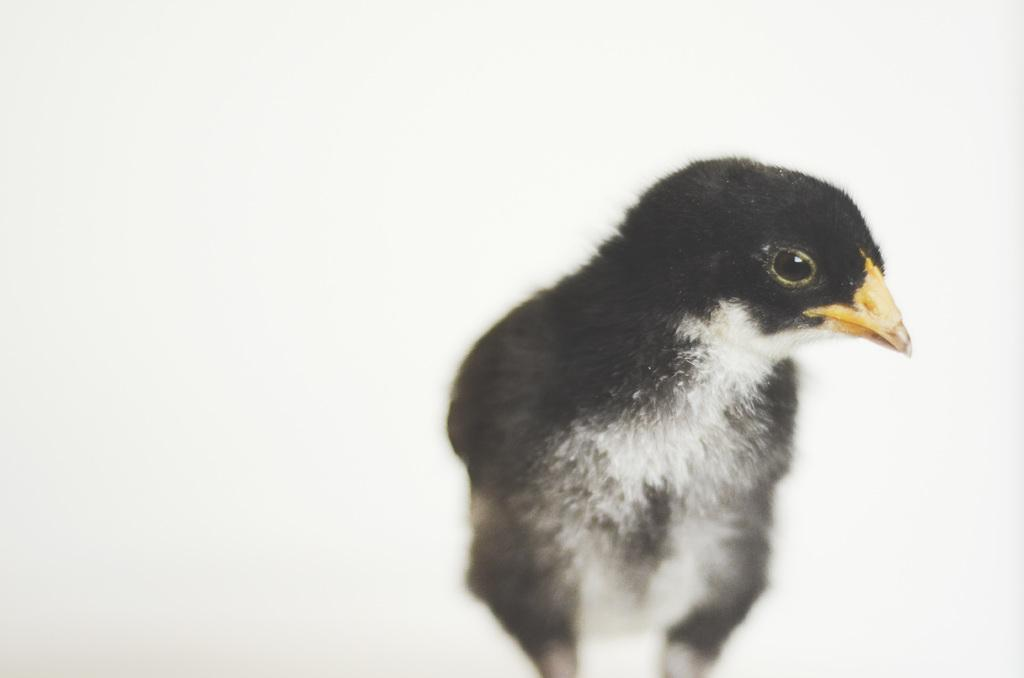What color is the background of the image? The background of the image is white. What is the main subject in the middle of the image? There is a bird in the middle of the image. What is the color of the bird? The bird is black in color. What type of house is the bird attempting to build in the image? There is no house or building activity depicted in the image; it features a black bird on a white background. 